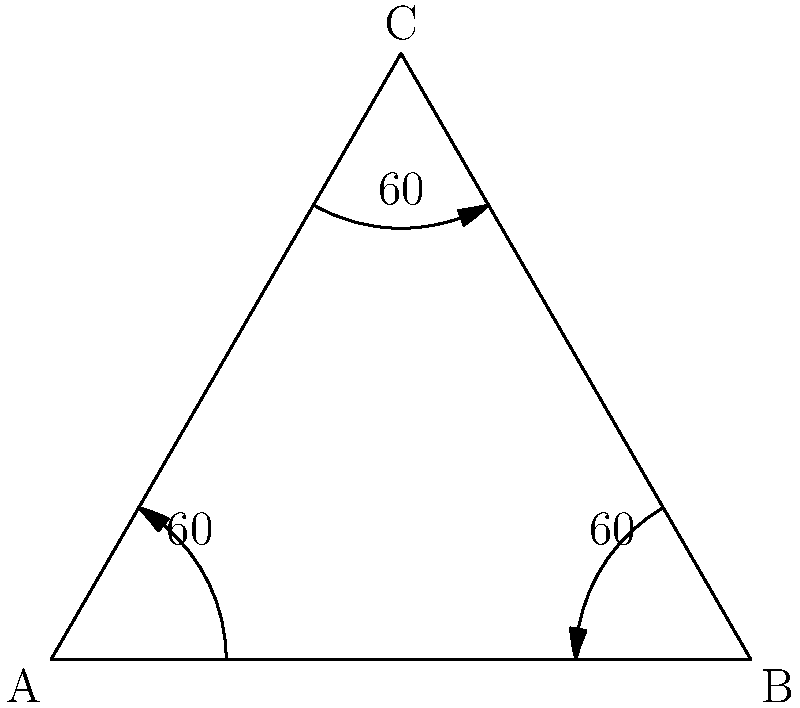In a classic ballet arabesque position, the dancer's supporting leg forms a 60° angle with the floor, while the working leg is extended behind at a 60° angle. If we consider this pose as an equilateral triangle, what would be the angle between the dancer's legs? Let's approach this step-by-step:

1) In an equilateral triangle, all sides are equal and all angles are 60°.

2) The supporting leg forms a 60° angle with the floor, which corresponds to one angle of the triangle.

3) The working leg extended behind also forms a 60° angle with the floor, corresponding to another angle of the triangle.

4) In any triangle, the sum of all angles is always 180°.

5) If two angles are 60° each, we can calculate the third angle:
   $180° - (60° + 60°) = 60°$

6) This third 60° angle represents the angle between the dancer's legs.

7) In an equilateral triangle, all angles are equal, which confirms our result.

Therefore, the angle between the dancer's legs in this arabesque position, represented as an equilateral triangle, would be 60°.
Answer: 60° 